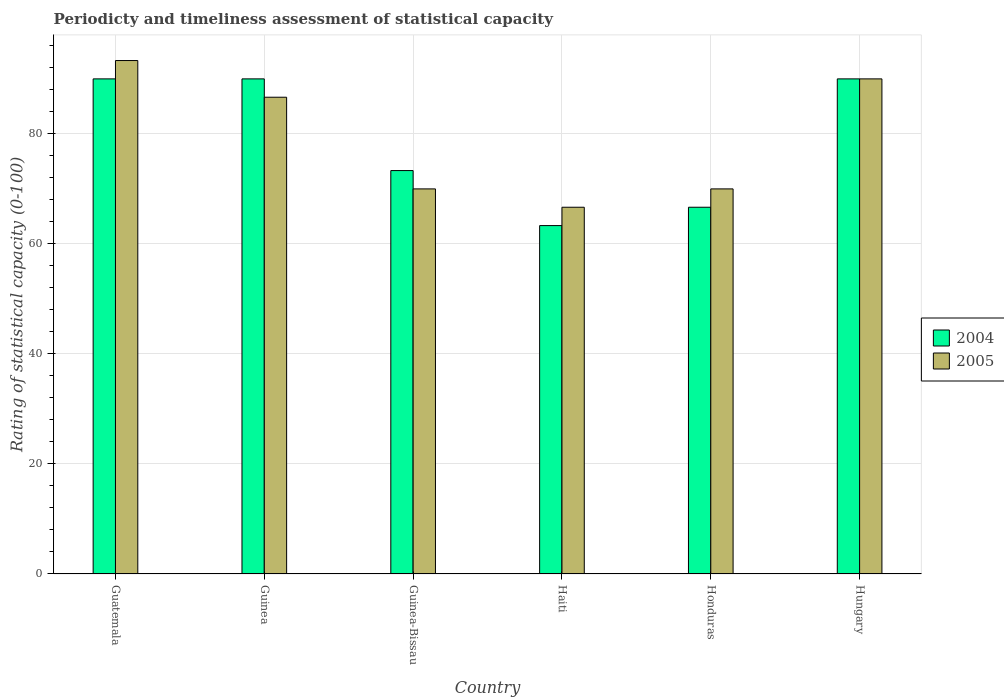How many different coloured bars are there?
Give a very brief answer. 2. Are the number of bars per tick equal to the number of legend labels?
Offer a very short reply. Yes. Are the number of bars on each tick of the X-axis equal?
Provide a succinct answer. Yes. What is the label of the 6th group of bars from the left?
Offer a very short reply. Hungary. What is the rating of statistical capacity in 2005 in Honduras?
Make the answer very short. 70. Across all countries, what is the maximum rating of statistical capacity in 2005?
Your response must be concise. 93.33. Across all countries, what is the minimum rating of statistical capacity in 2005?
Ensure brevity in your answer.  66.67. In which country was the rating of statistical capacity in 2004 maximum?
Give a very brief answer. Guatemala. In which country was the rating of statistical capacity in 2004 minimum?
Provide a succinct answer. Haiti. What is the total rating of statistical capacity in 2005 in the graph?
Your answer should be compact. 476.67. What is the difference between the rating of statistical capacity in 2004 in Guinea and that in Honduras?
Provide a succinct answer. 23.33. What is the difference between the rating of statistical capacity in 2005 in Hungary and the rating of statistical capacity in 2004 in Haiti?
Your response must be concise. 26.67. What is the average rating of statistical capacity in 2005 per country?
Make the answer very short. 79.44. What is the difference between the rating of statistical capacity of/in 2005 and rating of statistical capacity of/in 2004 in Honduras?
Your response must be concise. 3.33. What is the ratio of the rating of statistical capacity in 2004 in Haiti to that in Honduras?
Your answer should be very brief. 0.95. Is the difference between the rating of statistical capacity in 2005 in Haiti and Hungary greater than the difference between the rating of statistical capacity in 2004 in Haiti and Hungary?
Offer a very short reply. Yes. What is the difference between the highest and the second highest rating of statistical capacity in 2005?
Your response must be concise. -3.33. What is the difference between the highest and the lowest rating of statistical capacity in 2005?
Offer a very short reply. 26.67. Is the sum of the rating of statistical capacity in 2004 in Haiti and Honduras greater than the maximum rating of statistical capacity in 2005 across all countries?
Provide a short and direct response. Yes. How many bars are there?
Your response must be concise. 12. Are all the bars in the graph horizontal?
Offer a terse response. No. How many countries are there in the graph?
Offer a very short reply. 6. What is the difference between two consecutive major ticks on the Y-axis?
Provide a short and direct response. 20. Are the values on the major ticks of Y-axis written in scientific E-notation?
Give a very brief answer. No. Does the graph contain grids?
Make the answer very short. Yes. How are the legend labels stacked?
Offer a terse response. Vertical. What is the title of the graph?
Offer a terse response. Periodicty and timeliness assessment of statistical capacity. What is the label or title of the X-axis?
Your answer should be very brief. Country. What is the label or title of the Y-axis?
Your answer should be compact. Rating of statistical capacity (0-100). What is the Rating of statistical capacity (0-100) of 2004 in Guatemala?
Make the answer very short. 90. What is the Rating of statistical capacity (0-100) in 2005 in Guatemala?
Offer a terse response. 93.33. What is the Rating of statistical capacity (0-100) in 2004 in Guinea?
Offer a very short reply. 90. What is the Rating of statistical capacity (0-100) in 2005 in Guinea?
Offer a terse response. 86.67. What is the Rating of statistical capacity (0-100) in 2004 in Guinea-Bissau?
Make the answer very short. 73.33. What is the Rating of statistical capacity (0-100) in 2005 in Guinea-Bissau?
Offer a very short reply. 70. What is the Rating of statistical capacity (0-100) of 2004 in Haiti?
Provide a short and direct response. 63.33. What is the Rating of statistical capacity (0-100) in 2005 in Haiti?
Give a very brief answer. 66.67. What is the Rating of statistical capacity (0-100) in 2004 in Honduras?
Your answer should be compact. 66.67. What is the Rating of statistical capacity (0-100) of 2005 in Honduras?
Offer a very short reply. 70. What is the Rating of statistical capacity (0-100) in 2005 in Hungary?
Your answer should be very brief. 90. Across all countries, what is the maximum Rating of statistical capacity (0-100) in 2004?
Ensure brevity in your answer.  90. Across all countries, what is the maximum Rating of statistical capacity (0-100) of 2005?
Keep it short and to the point. 93.33. Across all countries, what is the minimum Rating of statistical capacity (0-100) in 2004?
Your answer should be very brief. 63.33. Across all countries, what is the minimum Rating of statistical capacity (0-100) in 2005?
Keep it short and to the point. 66.67. What is the total Rating of statistical capacity (0-100) in 2004 in the graph?
Provide a succinct answer. 473.33. What is the total Rating of statistical capacity (0-100) of 2005 in the graph?
Offer a very short reply. 476.67. What is the difference between the Rating of statistical capacity (0-100) of 2004 in Guatemala and that in Guinea-Bissau?
Your answer should be very brief. 16.67. What is the difference between the Rating of statistical capacity (0-100) of 2005 in Guatemala and that in Guinea-Bissau?
Your response must be concise. 23.33. What is the difference between the Rating of statistical capacity (0-100) of 2004 in Guatemala and that in Haiti?
Ensure brevity in your answer.  26.67. What is the difference between the Rating of statistical capacity (0-100) of 2005 in Guatemala and that in Haiti?
Offer a terse response. 26.67. What is the difference between the Rating of statistical capacity (0-100) in 2004 in Guatemala and that in Honduras?
Provide a succinct answer. 23.33. What is the difference between the Rating of statistical capacity (0-100) in 2005 in Guatemala and that in Honduras?
Your response must be concise. 23.33. What is the difference between the Rating of statistical capacity (0-100) of 2004 in Guinea and that in Guinea-Bissau?
Keep it short and to the point. 16.67. What is the difference between the Rating of statistical capacity (0-100) in 2005 in Guinea and that in Guinea-Bissau?
Offer a terse response. 16.67. What is the difference between the Rating of statistical capacity (0-100) in 2004 in Guinea and that in Haiti?
Provide a succinct answer. 26.67. What is the difference between the Rating of statistical capacity (0-100) of 2004 in Guinea and that in Honduras?
Keep it short and to the point. 23.33. What is the difference between the Rating of statistical capacity (0-100) of 2005 in Guinea and that in Honduras?
Your answer should be compact. 16.67. What is the difference between the Rating of statistical capacity (0-100) in 2004 in Guinea and that in Hungary?
Your answer should be very brief. 0. What is the difference between the Rating of statistical capacity (0-100) of 2005 in Guinea and that in Hungary?
Your answer should be compact. -3.33. What is the difference between the Rating of statistical capacity (0-100) of 2004 in Guinea-Bissau and that in Haiti?
Your answer should be compact. 10. What is the difference between the Rating of statistical capacity (0-100) in 2004 in Guinea-Bissau and that in Honduras?
Your answer should be compact. 6.67. What is the difference between the Rating of statistical capacity (0-100) in 2004 in Guinea-Bissau and that in Hungary?
Offer a terse response. -16.67. What is the difference between the Rating of statistical capacity (0-100) in 2005 in Guinea-Bissau and that in Hungary?
Give a very brief answer. -20. What is the difference between the Rating of statistical capacity (0-100) in 2005 in Haiti and that in Honduras?
Provide a succinct answer. -3.33. What is the difference between the Rating of statistical capacity (0-100) in 2004 in Haiti and that in Hungary?
Give a very brief answer. -26.67. What is the difference between the Rating of statistical capacity (0-100) of 2005 in Haiti and that in Hungary?
Give a very brief answer. -23.33. What is the difference between the Rating of statistical capacity (0-100) in 2004 in Honduras and that in Hungary?
Offer a terse response. -23.33. What is the difference between the Rating of statistical capacity (0-100) of 2004 in Guatemala and the Rating of statistical capacity (0-100) of 2005 in Guinea?
Ensure brevity in your answer.  3.33. What is the difference between the Rating of statistical capacity (0-100) in 2004 in Guatemala and the Rating of statistical capacity (0-100) in 2005 in Guinea-Bissau?
Offer a very short reply. 20. What is the difference between the Rating of statistical capacity (0-100) of 2004 in Guatemala and the Rating of statistical capacity (0-100) of 2005 in Haiti?
Make the answer very short. 23.33. What is the difference between the Rating of statistical capacity (0-100) in 2004 in Guinea and the Rating of statistical capacity (0-100) in 2005 in Guinea-Bissau?
Keep it short and to the point. 20. What is the difference between the Rating of statistical capacity (0-100) in 2004 in Guinea and the Rating of statistical capacity (0-100) in 2005 in Haiti?
Make the answer very short. 23.33. What is the difference between the Rating of statistical capacity (0-100) of 2004 in Guinea and the Rating of statistical capacity (0-100) of 2005 in Honduras?
Give a very brief answer. 20. What is the difference between the Rating of statistical capacity (0-100) of 2004 in Guinea-Bissau and the Rating of statistical capacity (0-100) of 2005 in Haiti?
Keep it short and to the point. 6.67. What is the difference between the Rating of statistical capacity (0-100) in 2004 in Guinea-Bissau and the Rating of statistical capacity (0-100) in 2005 in Hungary?
Your answer should be very brief. -16.67. What is the difference between the Rating of statistical capacity (0-100) of 2004 in Haiti and the Rating of statistical capacity (0-100) of 2005 in Honduras?
Provide a short and direct response. -6.67. What is the difference between the Rating of statistical capacity (0-100) of 2004 in Haiti and the Rating of statistical capacity (0-100) of 2005 in Hungary?
Provide a short and direct response. -26.67. What is the difference between the Rating of statistical capacity (0-100) of 2004 in Honduras and the Rating of statistical capacity (0-100) of 2005 in Hungary?
Your answer should be very brief. -23.33. What is the average Rating of statistical capacity (0-100) in 2004 per country?
Your response must be concise. 78.89. What is the average Rating of statistical capacity (0-100) in 2005 per country?
Provide a short and direct response. 79.44. What is the difference between the Rating of statistical capacity (0-100) of 2004 and Rating of statistical capacity (0-100) of 2005 in Guatemala?
Make the answer very short. -3.33. What is the difference between the Rating of statistical capacity (0-100) in 2004 and Rating of statistical capacity (0-100) in 2005 in Guinea?
Your answer should be compact. 3.33. What is the difference between the Rating of statistical capacity (0-100) of 2004 and Rating of statistical capacity (0-100) of 2005 in Guinea-Bissau?
Make the answer very short. 3.33. What is the difference between the Rating of statistical capacity (0-100) in 2004 and Rating of statistical capacity (0-100) in 2005 in Haiti?
Your answer should be very brief. -3.33. What is the difference between the Rating of statistical capacity (0-100) of 2004 and Rating of statistical capacity (0-100) of 2005 in Honduras?
Offer a terse response. -3.33. What is the ratio of the Rating of statistical capacity (0-100) in 2004 in Guatemala to that in Guinea-Bissau?
Your answer should be very brief. 1.23. What is the ratio of the Rating of statistical capacity (0-100) in 2005 in Guatemala to that in Guinea-Bissau?
Provide a succinct answer. 1.33. What is the ratio of the Rating of statistical capacity (0-100) of 2004 in Guatemala to that in Haiti?
Provide a succinct answer. 1.42. What is the ratio of the Rating of statistical capacity (0-100) of 2005 in Guatemala to that in Haiti?
Make the answer very short. 1.4. What is the ratio of the Rating of statistical capacity (0-100) of 2004 in Guatemala to that in Honduras?
Make the answer very short. 1.35. What is the ratio of the Rating of statistical capacity (0-100) in 2005 in Guatemala to that in Honduras?
Provide a short and direct response. 1.33. What is the ratio of the Rating of statistical capacity (0-100) of 2005 in Guatemala to that in Hungary?
Your answer should be very brief. 1.04. What is the ratio of the Rating of statistical capacity (0-100) in 2004 in Guinea to that in Guinea-Bissau?
Give a very brief answer. 1.23. What is the ratio of the Rating of statistical capacity (0-100) of 2005 in Guinea to that in Guinea-Bissau?
Offer a terse response. 1.24. What is the ratio of the Rating of statistical capacity (0-100) of 2004 in Guinea to that in Haiti?
Offer a terse response. 1.42. What is the ratio of the Rating of statistical capacity (0-100) in 2004 in Guinea to that in Honduras?
Keep it short and to the point. 1.35. What is the ratio of the Rating of statistical capacity (0-100) of 2005 in Guinea to that in Honduras?
Offer a terse response. 1.24. What is the ratio of the Rating of statistical capacity (0-100) in 2004 in Guinea to that in Hungary?
Keep it short and to the point. 1. What is the ratio of the Rating of statistical capacity (0-100) of 2005 in Guinea to that in Hungary?
Give a very brief answer. 0.96. What is the ratio of the Rating of statistical capacity (0-100) of 2004 in Guinea-Bissau to that in Haiti?
Your answer should be very brief. 1.16. What is the ratio of the Rating of statistical capacity (0-100) of 2004 in Guinea-Bissau to that in Honduras?
Your answer should be very brief. 1.1. What is the ratio of the Rating of statistical capacity (0-100) of 2004 in Guinea-Bissau to that in Hungary?
Your response must be concise. 0.81. What is the ratio of the Rating of statistical capacity (0-100) of 2005 in Guinea-Bissau to that in Hungary?
Make the answer very short. 0.78. What is the ratio of the Rating of statistical capacity (0-100) in 2005 in Haiti to that in Honduras?
Provide a succinct answer. 0.95. What is the ratio of the Rating of statistical capacity (0-100) in 2004 in Haiti to that in Hungary?
Your response must be concise. 0.7. What is the ratio of the Rating of statistical capacity (0-100) in 2005 in Haiti to that in Hungary?
Keep it short and to the point. 0.74. What is the ratio of the Rating of statistical capacity (0-100) in 2004 in Honduras to that in Hungary?
Provide a succinct answer. 0.74. What is the difference between the highest and the lowest Rating of statistical capacity (0-100) of 2004?
Your response must be concise. 26.67. What is the difference between the highest and the lowest Rating of statistical capacity (0-100) of 2005?
Provide a succinct answer. 26.67. 